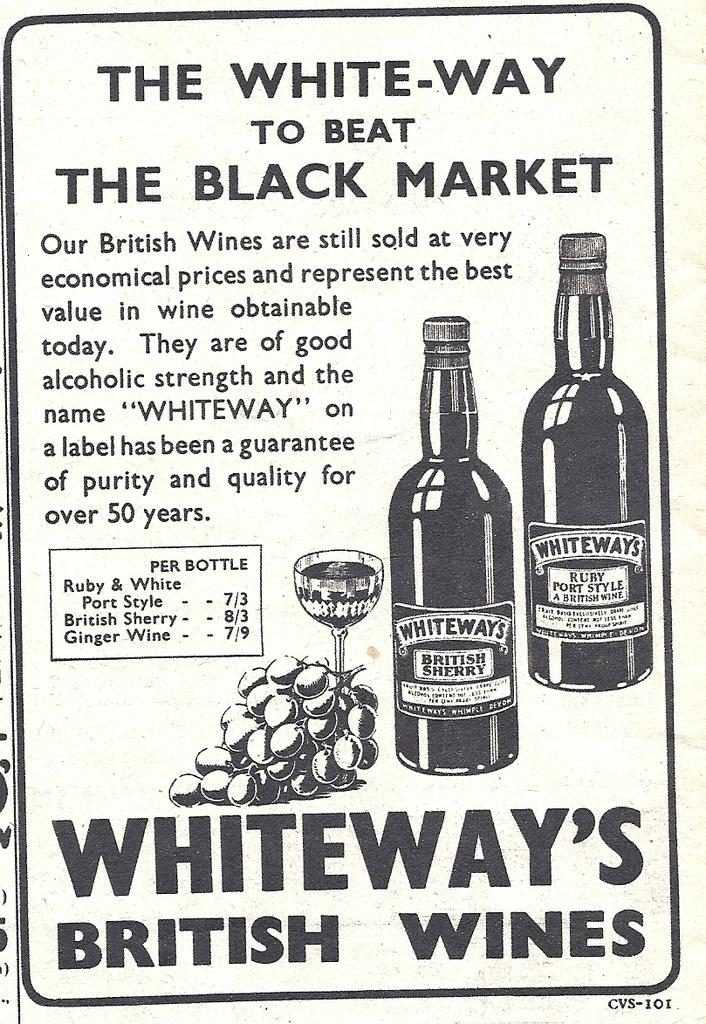<image>
Present a compact description of the photo's key features. A poster talks about Whiteway British wines as a guarantee for quality. 